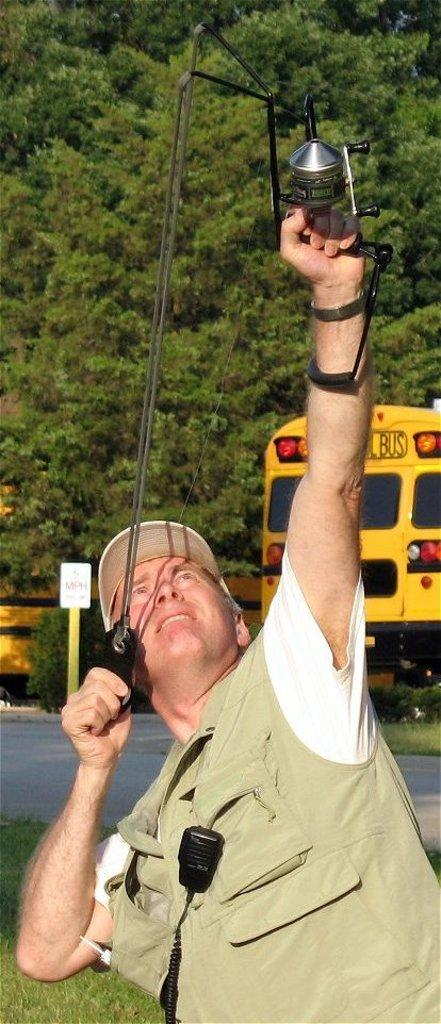What is the main subject of the image? There is a man in the image. What is the man holding in the image? The man is holding an object. Can you describe the man's attire in the image? The man is wearing a hat. What can be seen in the background of the image? There is a yellow color bus and green color trees in the background of the image. What historical event is the man trying to stop in the image? There is no indication of a historical event or any attempt to stop one in the image. 